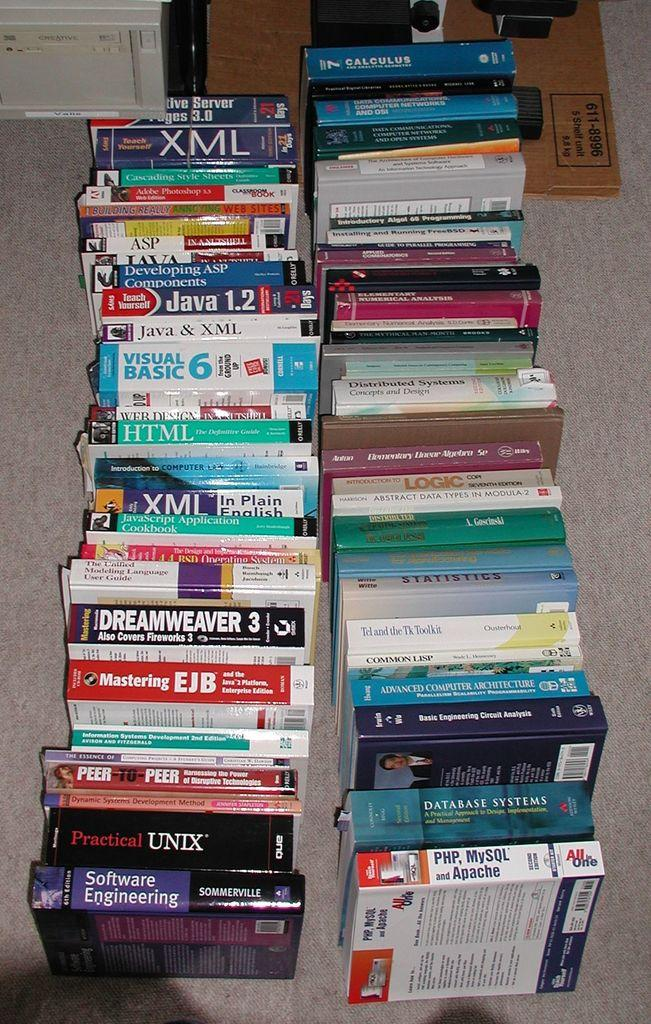Provide a one-sentence caption for the provided image. A large collection of books with one named XML. 